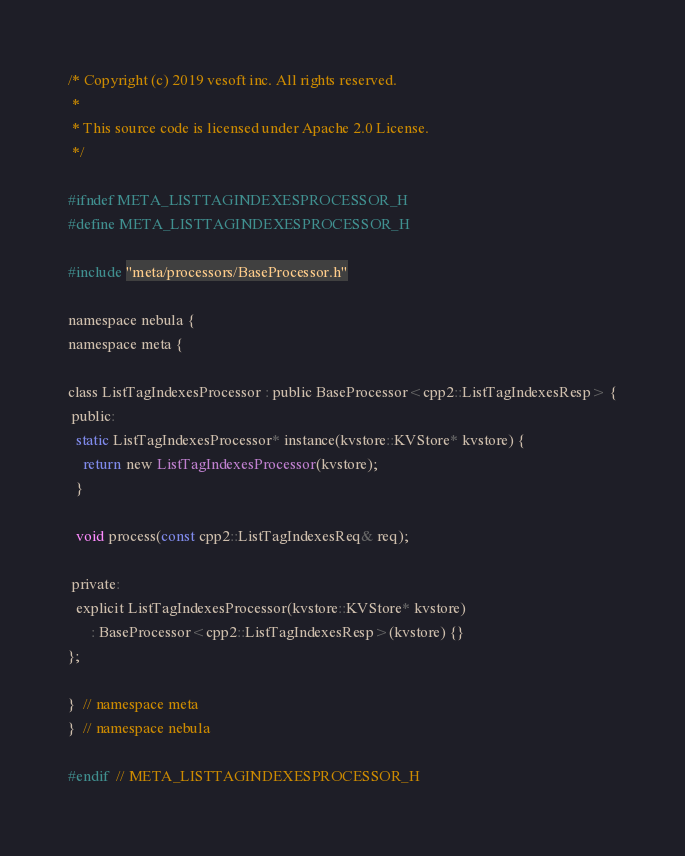Convert code to text. <code><loc_0><loc_0><loc_500><loc_500><_C_>/* Copyright (c) 2019 vesoft inc. All rights reserved.
 *
 * This source code is licensed under Apache 2.0 License.
 */

#ifndef META_LISTTAGINDEXESPROCESSOR_H
#define META_LISTTAGINDEXESPROCESSOR_H

#include "meta/processors/BaseProcessor.h"

namespace nebula {
namespace meta {

class ListTagIndexesProcessor : public BaseProcessor<cpp2::ListTagIndexesResp> {
 public:
  static ListTagIndexesProcessor* instance(kvstore::KVStore* kvstore) {
    return new ListTagIndexesProcessor(kvstore);
  }

  void process(const cpp2::ListTagIndexesReq& req);

 private:
  explicit ListTagIndexesProcessor(kvstore::KVStore* kvstore)
      : BaseProcessor<cpp2::ListTagIndexesResp>(kvstore) {}
};

}  // namespace meta
}  // namespace nebula

#endif  // META_LISTTAGINDEXESPROCESSOR_H
</code> 